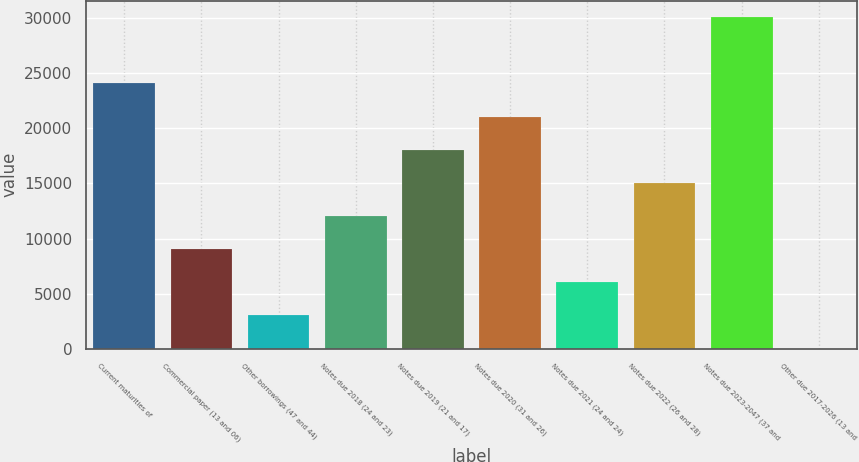<chart> <loc_0><loc_0><loc_500><loc_500><bar_chart><fcel>Current maturities of<fcel>Commercial paper (13 and 06)<fcel>Other borrowings (47 and 44)<fcel>Notes due 2018 (24 and 23)<fcel>Notes due 2019 (21 and 17)<fcel>Notes due 2020 (31 and 26)<fcel>Notes due 2021 (24 and 24)<fcel>Notes due 2022 (26 and 28)<fcel>Notes due 2023-2047 (37 and<fcel>Other due 2017-2026 (13 and<nl><fcel>24049.4<fcel>9040.4<fcel>3036.8<fcel>12042.2<fcel>18045.8<fcel>21047.6<fcel>6038.6<fcel>15044<fcel>30053<fcel>35<nl></chart> 